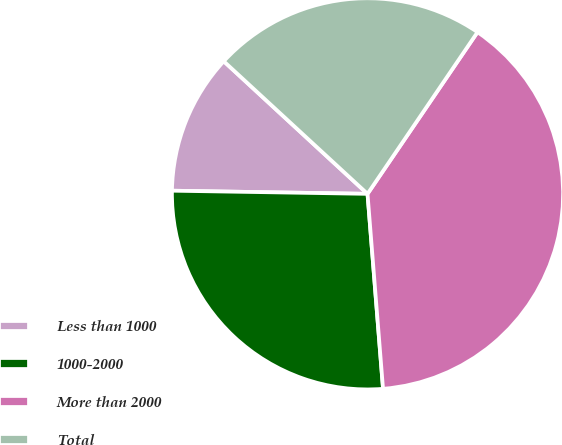<chart> <loc_0><loc_0><loc_500><loc_500><pie_chart><fcel>Less than 1000<fcel>1000-2000<fcel>More than 2000<fcel>Total<nl><fcel>11.6%<fcel>26.52%<fcel>39.23%<fcel>22.65%<nl></chart> 